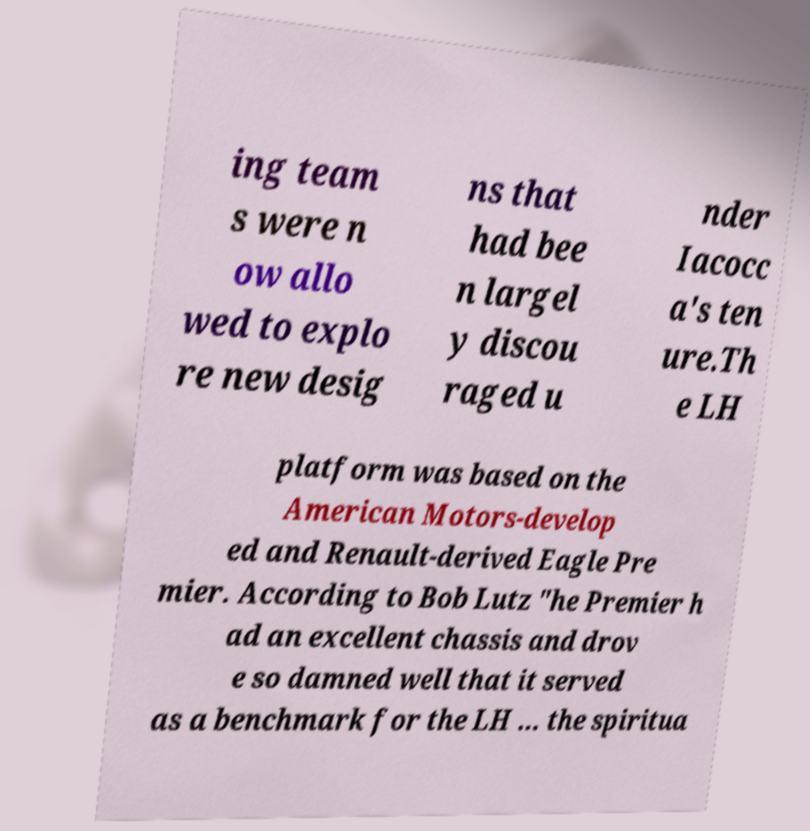For documentation purposes, I need the text within this image transcribed. Could you provide that? ing team s were n ow allo wed to explo re new desig ns that had bee n largel y discou raged u nder Iacocc a's ten ure.Th e LH platform was based on the American Motors-develop ed and Renault-derived Eagle Pre mier. According to Bob Lutz "he Premier h ad an excellent chassis and drov e so damned well that it served as a benchmark for the LH ... the spiritua 